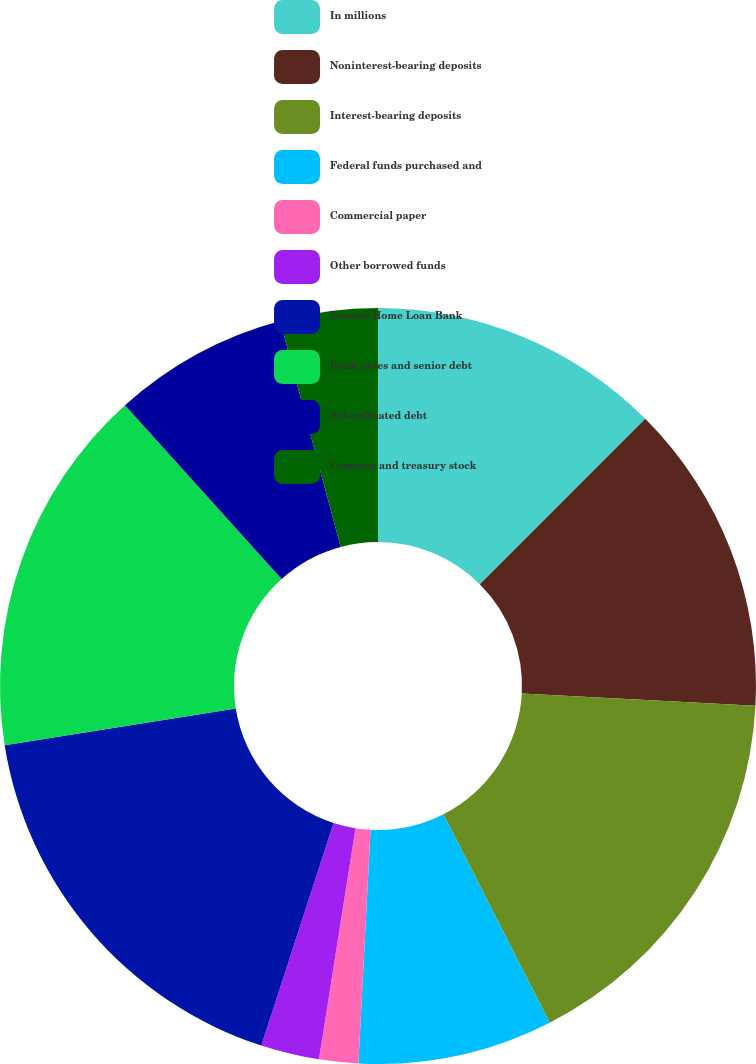Convert chart. <chart><loc_0><loc_0><loc_500><loc_500><pie_chart><fcel>In millions<fcel>Noninterest-bearing deposits<fcel>Interest-bearing deposits<fcel>Federal funds purchased and<fcel>Commercial paper<fcel>Other borrowed funds<fcel>Federal Home Loan Bank<fcel>Bank notes and senior debt<fcel>Subordinated debt<fcel>Common and treasury stock<nl><fcel>12.5%<fcel>13.33%<fcel>16.66%<fcel>8.33%<fcel>1.67%<fcel>2.5%<fcel>17.5%<fcel>15.83%<fcel>7.5%<fcel>4.17%<nl></chart> 